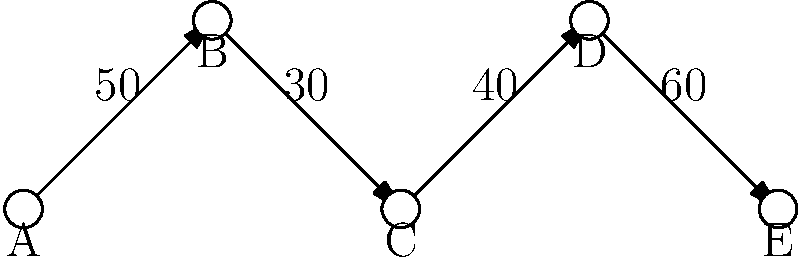In the supply chain network diagram above, nodes represent different stages in the supply chain, and the numbers on the edges represent the maximum daily throughput capacity between stages. What is the maximum daily throughput of the entire supply chain, and which stage represents the bottleneck? To identify the bottleneck and determine the maximum daily throughput of the entire supply chain, we need to follow these steps:

1. Analyze each stage of the supply chain:
   - A to B: 50 units/day
   - B to C: 30 units/day
   - C to D: 40 units/day
   - D to E: 60 units/day

2. Identify the bottleneck:
   The bottleneck is the stage with the lowest throughput capacity, as it limits the overall flow of the entire chain. In this case, the bottleneck is between stages B and C, with a capacity of 30 units/day.

3. Determine the maximum daily throughput:
   The maximum daily throughput of the entire supply chain is limited by the bottleneck. Therefore, the maximum throughput is 30 units/day.

4. Identify the bottleneck stage:
   The bottleneck occurs at stage B, as it is the starting point of the edge with the lowest capacity.

Thus, the maximum daily throughput of the entire supply chain is 30 units/day, and stage B represents the bottleneck.
Answer: 30 units/day; Stage B 